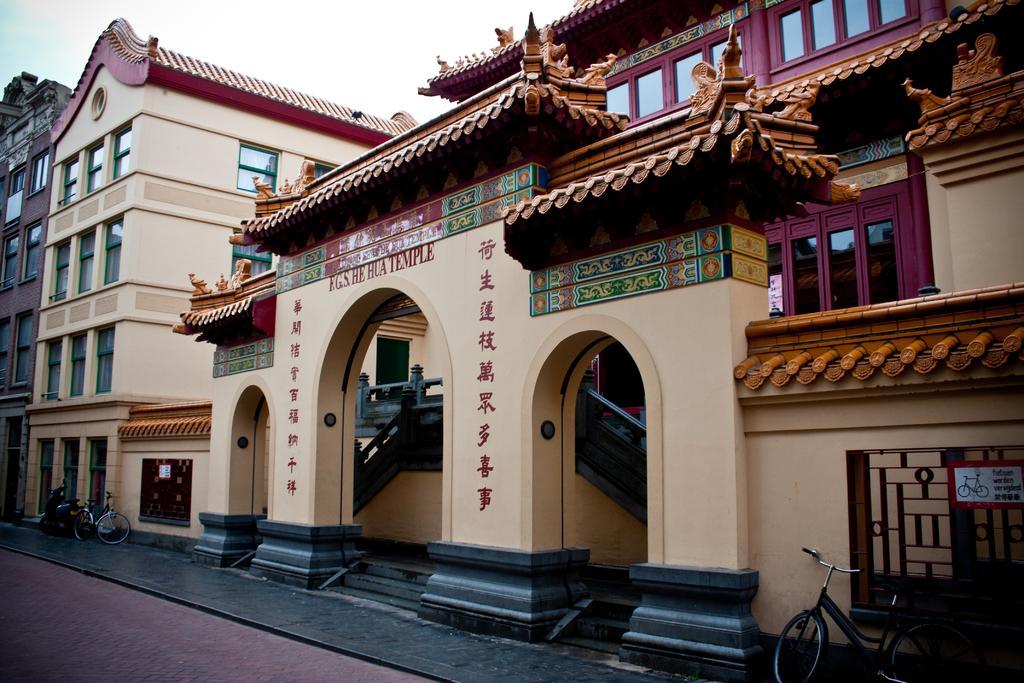In one or two sentences, can you explain what this image depicts? In the given image i can see a heritage building with windows,vehicles,stairs,gate,board and in the background i can see the sky. 